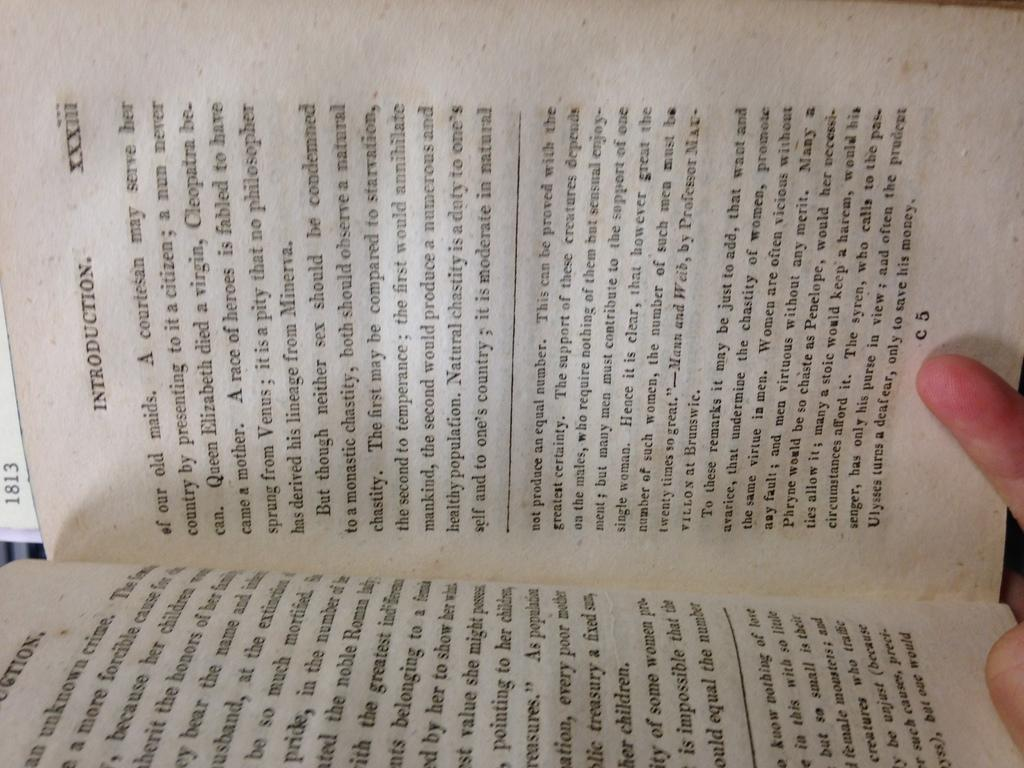<image>
Present a compact description of the photo's key features. An book turned sideways, opened to a page in the introduction. 